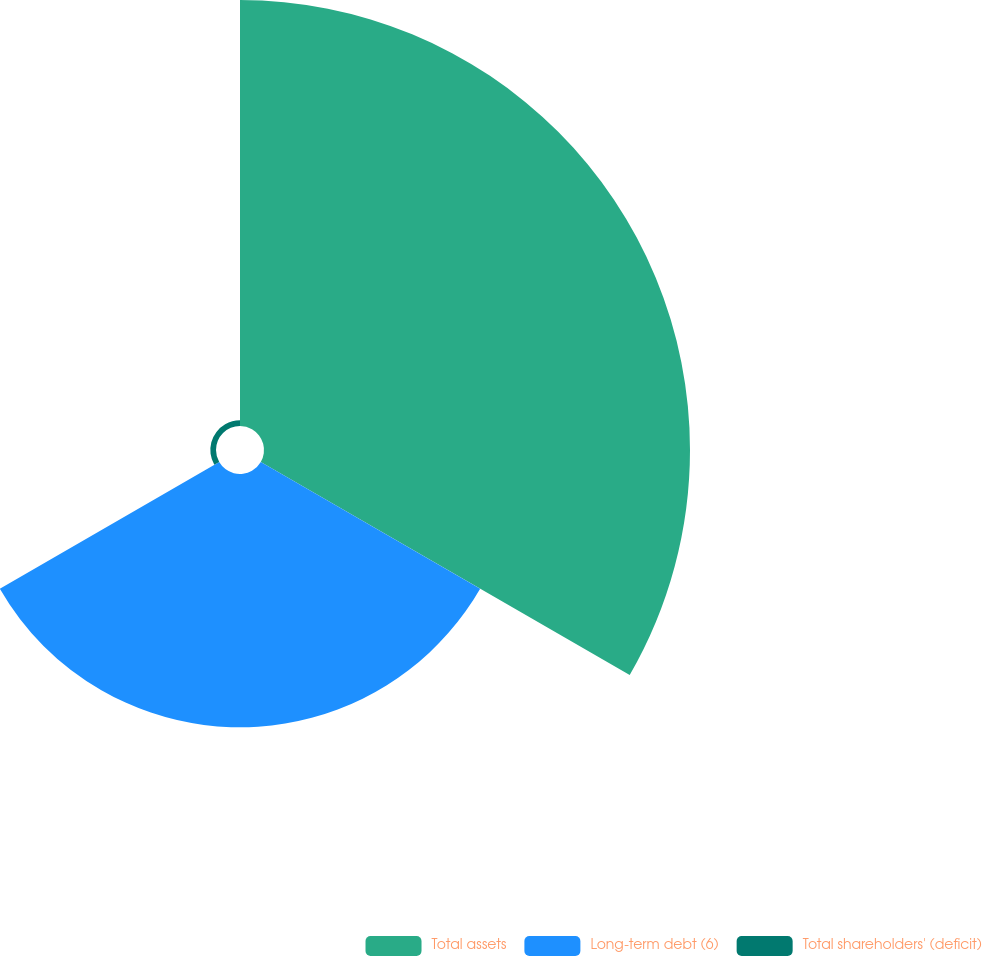Convert chart. <chart><loc_0><loc_0><loc_500><loc_500><pie_chart><fcel>Total assets<fcel>Long-term debt (6)<fcel>Total shareholders' (deficit)<nl><fcel>62.19%<fcel>36.98%<fcel>0.83%<nl></chart> 